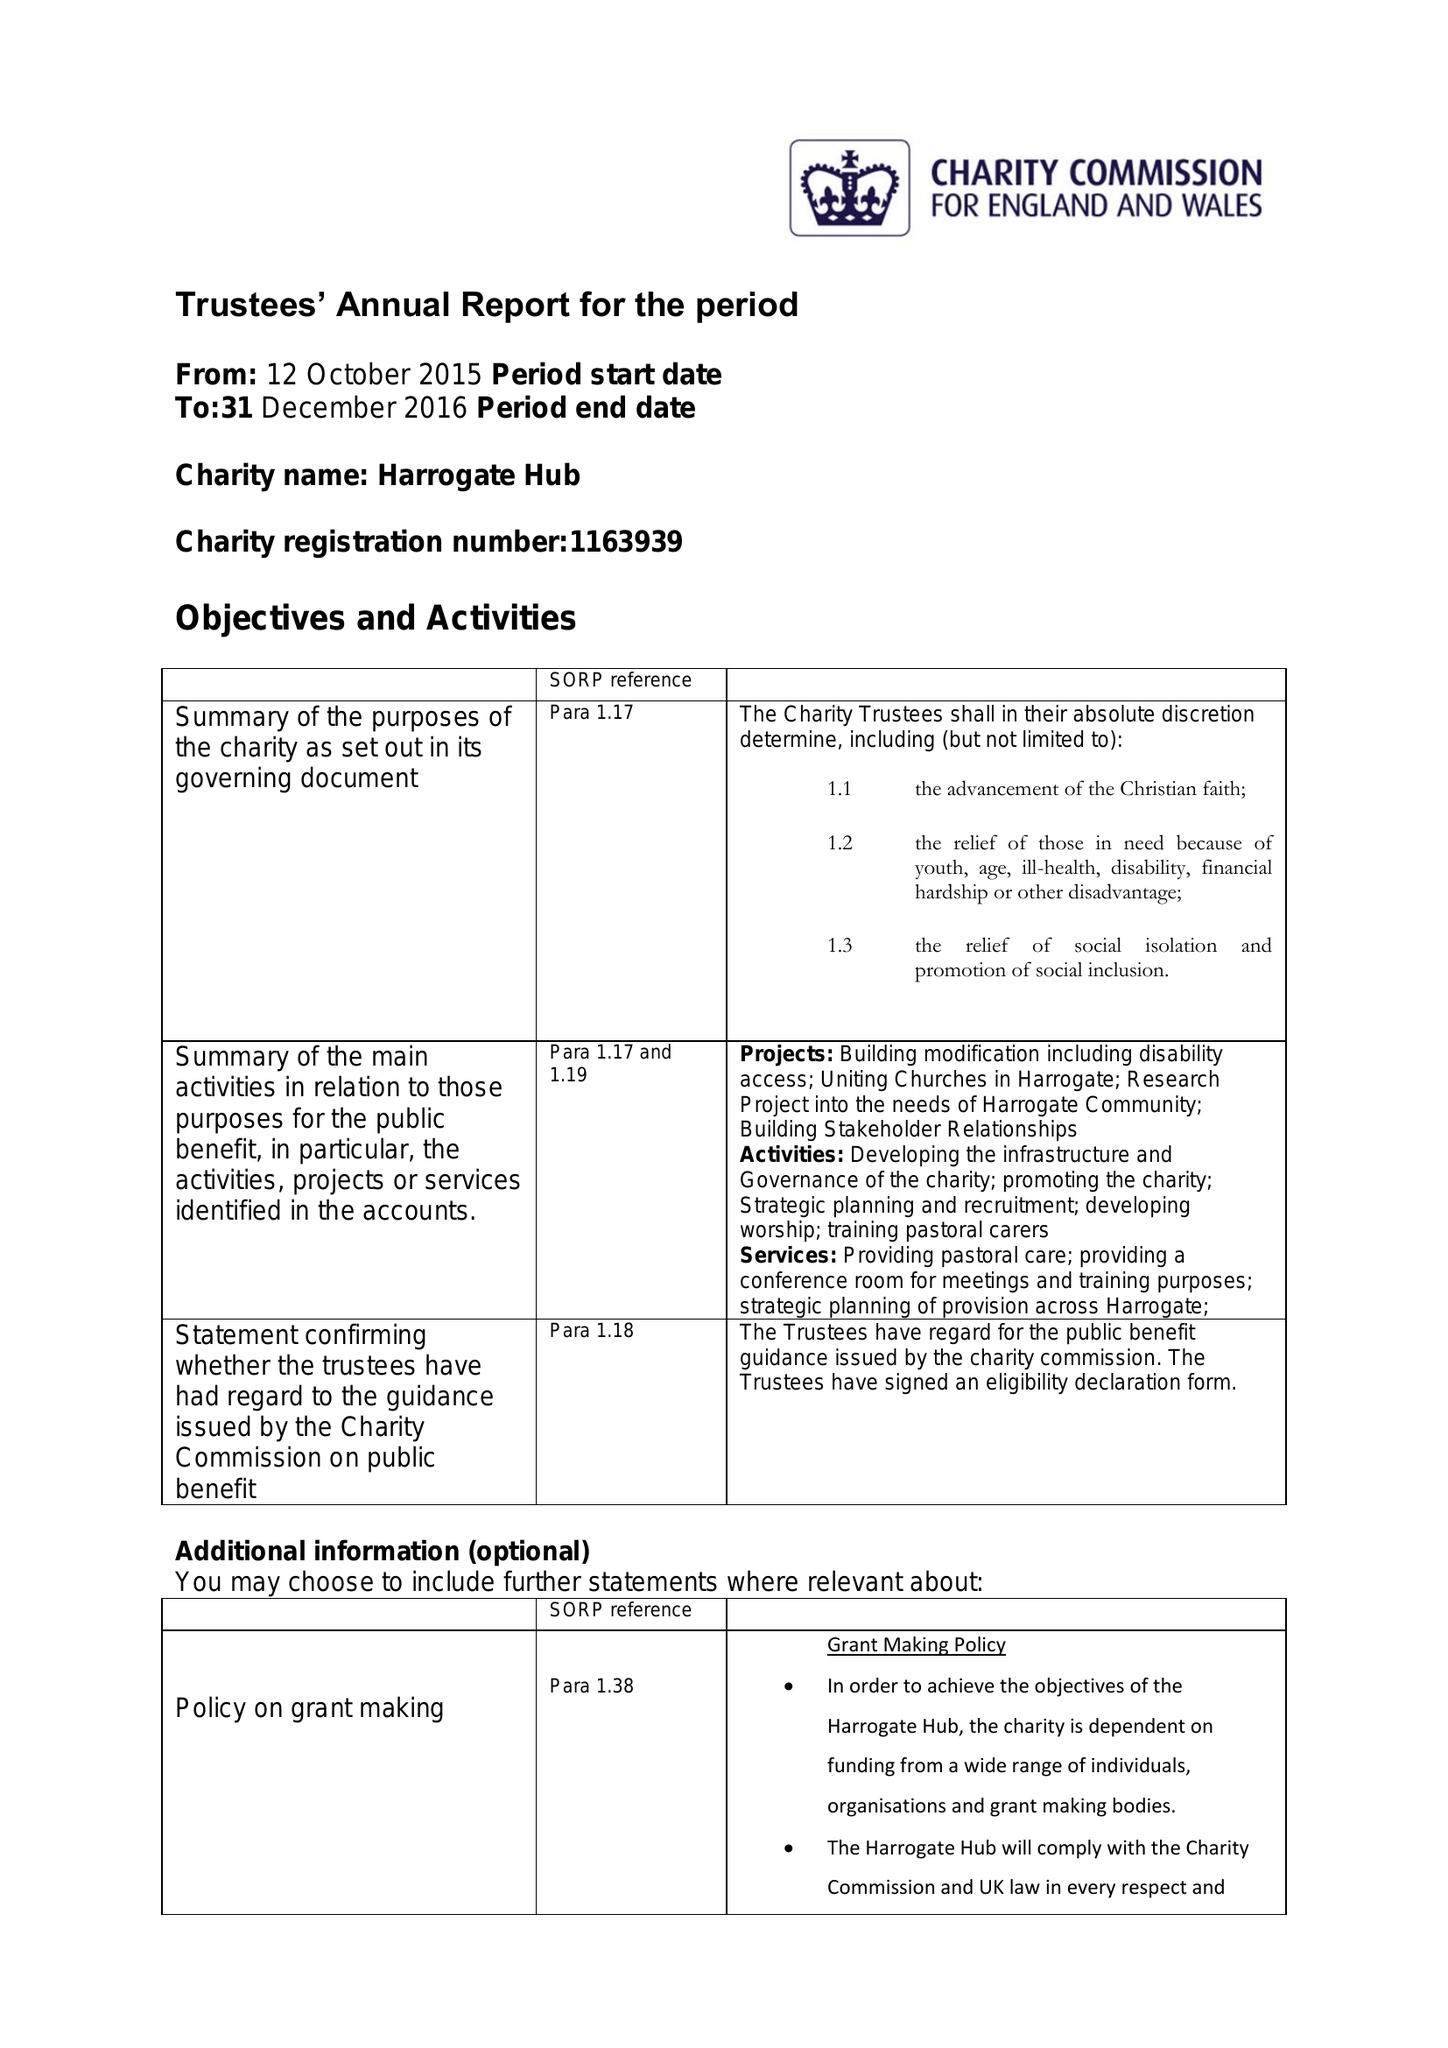What is the value for the spending_annually_in_british_pounds?
Answer the question using a single word or phrase. 117430.00 